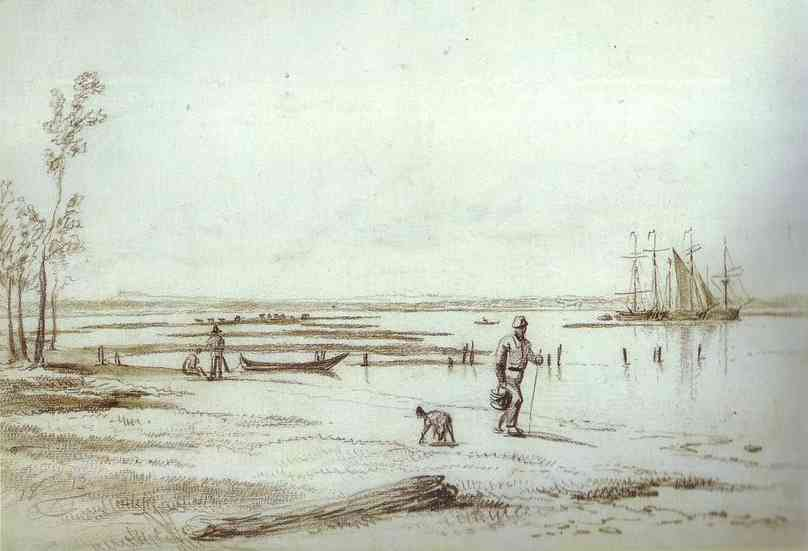What is the mood conveyed by this image, and how is it achieved? The mood conveyed by this image is one of tranquility and reflective calm. It is achieved through the gentle lines, the soft, muted color palette predominantly featuring browns, grays, and greens, as well as the calm, still waters and the distant perspective. Each of these elements works together to create a scene that invites the viewer to pause and reflect, evoking a sense of peace and timelessness. 